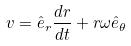Convert formula to latex. <formula><loc_0><loc_0><loc_500><loc_500>v = \hat { e } _ { r } \frac { d r } { d t } + r \omega \hat { e } _ { \theta }</formula> 